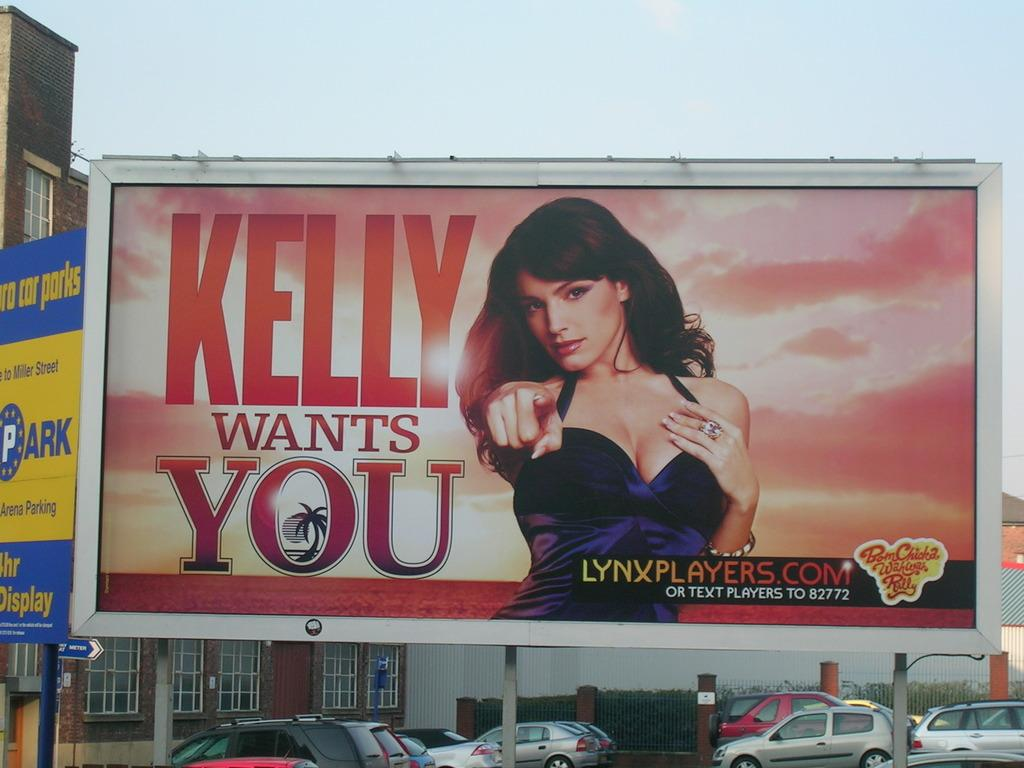<image>
Render a clear and concise summary of the photo. A billboard advertisement with a woman pointing that says Kelly wants you 